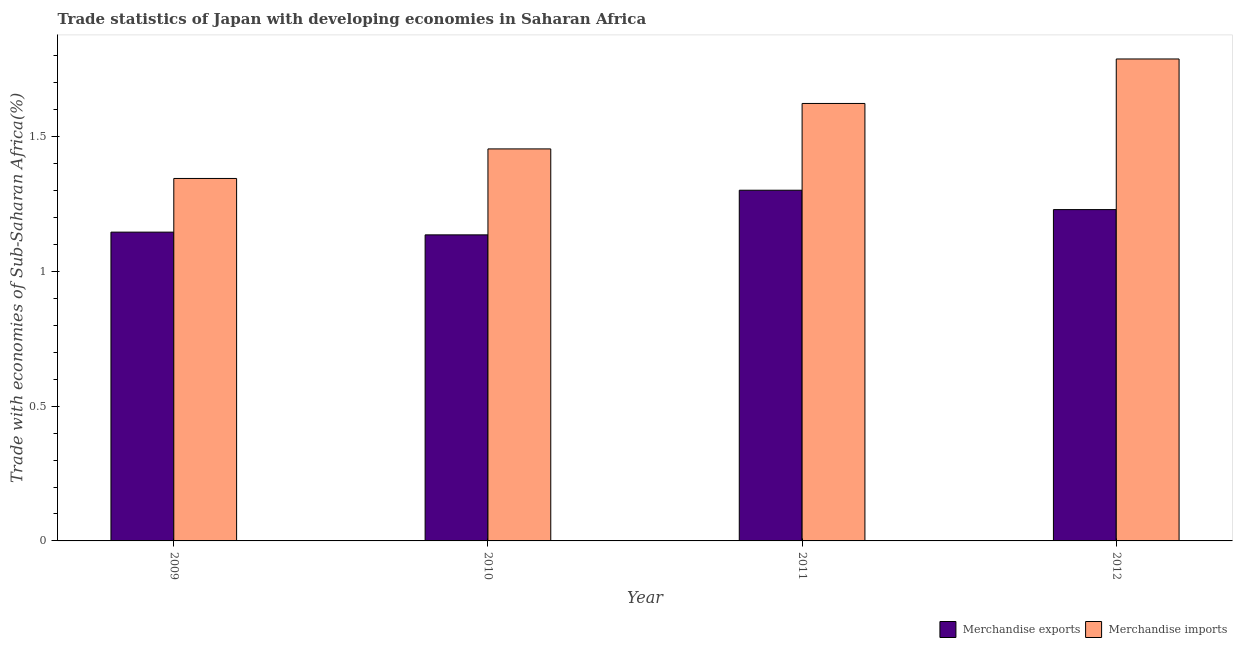Are the number of bars on each tick of the X-axis equal?
Your answer should be compact. Yes. How many bars are there on the 2nd tick from the left?
Your answer should be compact. 2. How many bars are there on the 2nd tick from the right?
Keep it short and to the point. 2. What is the label of the 3rd group of bars from the left?
Your answer should be compact. 2011. What is the merchandise imports in 2009?
Your answer should be very brief. 1.35. Across all years, what is the maximum merchandise exports?
Give a very brief answer. 1.3. Across all years, what is the minimum merchandise imports?
Ensure brevity in your answer.  1.35. In which year was the merchandise imports minimum?
Your answer should be compact. 2009. What is the total merchandise exports in the graph?
Offer a very short reply. 4.81. What is the difference between the merchandise imports in 2011 and that in 2012?
Ensure brevity in your answer.  -0.17. What is the difference between the merchandise exports in 2012 and the merchandise imports in 2009?
Make the answer very short. 0.08. What is the average merchandise imports per year?
Provide a short and direct response. 1.55. What is the ratio of the merchandise exports in 2010 to that in 2011?
Give a very brief answer. 0.87. What is the difference between the highest and the second highest merchandise imports?
Your answer should be compact. 0.17. What is the difference between the highest and the lowest merchandise exports?
Offer a terse response. 0.17. In how many years, is the merchandise exports greater than the average merchandise exports taken over all years?
Your response must be concise. 2. Is the sum of the merchandise imports in 2009 and 2010 greater than the maximum merchandise exports across all years?
Your answer should be compact. Yes. What does the 1st bar from the left in 2011 represents?
Your response must be concise. Merchandise exports. What does the 1st bar from the right in 2011 represents?
Offer a very short reply. Merchandise imports. How many bars are there?
Make the answer very short. 8. Are all the bars in the graph horizontal?
Ensure brevity in your answer.  No. Are the values on the major ticks of Y-axis written in scientific E-notation?
Your answer should be very brief. No. Does the graph contain grids?
Make the answer very short. No. How are the legend labels stacked?
Provide a short and direct response. Horizontal. What is the title of the graph?
Offer a terse response. Trade statistics of Japan with developing economies in Saharan Africa. What is the label or title of the Y-axis?
Your answer should be compact. Trade with economies of Sub-Saharan Africa(%). What is the Trade with economies of Sub-Saharan Africa(%) in Merchandise exports in 2009?
Provide a short and direct response. 1.15. What is the Trade with economies of Sub-Saharan Africa(%) in Merchandise imports in 2009?
Provide a succinct answer. 1.35. What is the Trade with economies of Sub-Saharan Africa(%) in Merchandise exports in 2010?
Offer a terse response. 1.14. What is the Trade with economies of Sub-Saharan Africa(%) of Merchandise imports in 2010?
Your answer should be very brief. 1.46. What is the Trade with economies of Sub-Saharan Africa(%) of Merchandise exports in 2011?
Offer a very short reply. 1.3. What is the Trade with economies of Sub-Saharan Africa(%) in Merchandise imports in 2011?
Your response must be concise. 1.62. What is the Trade with economies of Sub-Saharan Africa(%) of Merchandise exports in 2012?
Keep it short and to the point. 1.23. What is the Trade with economies of Sub-Saharan Africa(%) of Merchandise imports in 2012?
Make the answer very short. 1.79. Across all years, what is the maximum Trade with economies of Sub-Saharan Africa(%) in Merchandise exports?
Your answer should be compact. 1.3. Across all years, what is the maximum Trade with economies of Sub-Saharan Africa(%) in Merchandise imports?
Your answer should be compact. 1.79. Across all years, what is the minimum Trade with economies of Sub-Saharan Africa(%) in Merchandise exports?
Keep it short and to the point. 1.14. Across all years, what is the minimum Trade with economies of Sub-Saharan Africa(%) of Merchandise imports?
Give a very brief answer. 1.35. What is the total Trade with economies of Sub-Saharan Africa(%) of Merchandise exports in the graph?
Offer a very short reply. 4.81. What is the total Trade with economies of Sub-Saharan Africa(%) of Merchandise imports in the graph?
Offer a very short reply. 6.21. What is the difference between the Trade with economies of Sub-Saharan Africa(%) of Merchandise exports in 2009 and that in 2010?
Offer a very short reply. 0.01. What is the difference between the Trade with economies of Sub-Saharan Africa(%) of Merchandise imports in 2009 and that in 2010?
Give a very brief answer. -0.11. What is the difference between the Trade with economies of Sub-Saharan Africa(%) in Merchandise exports in 2009 and that in 2011?
Offer a terse response. -0.16. What is the difference between the Trade with economies of Sub-Saharan Africa(%) of Merchandise imports in 2009 and that in 2011?
Provide a succinct answer. -0.28. What is the difference between the Trade with economies of Sub-Saharan Africa(%) in Merchandise exports in 2009 and that in 2012?
Offer a terse response. -0.08. What is the difference between the Trade with economies of Sub-Saharan Africa(%) in Merchandise imports in 2009 and that in 2012?
Offer a very short reply. -0.44. What is the difference between the Trade with economies of Sub-Saharan Africa(%) in Merchandise exports in 2010 and that in 2011?
Your answer should be compact. -0.17. What is the difference between the Trade with economies of Sub-Saharan Africa(%) of Merchandise imports in 2010 and that in 2011?
Ensure brevity in your answer.  -0.17. What is the difference between the Trade with economies of Sub-Saharan Africa(%) in Merchandise exports in 2010 and that in 2012?
Provide a succinct answer. -0.09. What is the difference between the Trade with economies of Sub-Saharan Africa(%) in Merchandise imports in 2010 and that in 2012?
Keep it short and to the point. -0.33. What is the difference between the Trade with economies of Sub-Saharan Africa(%) of Merchandise exports in 2011 and that in 2012?
Keep it short and to the point. 0.07. What is the difference between the Trade with economies of Sub-Saharan Africa(%) of Merchandise imports in 2011 and that in 2012?
Your response must be concise. -0.17. What is the difference between the Trade with economies of Sub-Saharan Africa(%) of Merchandise exports in 2009 and the Trade with economies of Sub-Saharan Africa(%) of Merchandise imports in 2010?
Your response must be concise. -0.31. What is the difference between the Trade with economies of Sub-Saharan Africa(%) in Merchandise exports in 2009 and the Trade with economies of Sub-Saharan Africa(%) in Merchandise imports in 2011?
Keep it short and to the point. -0.48. What is the difference between the Trade with economies of Sub-Saharan Africa(%) of Merchandise exports in 2009 and the Trade with economies of Sub-Saharan Africa(%) of Merchandise imports in 2012?
Ensure brevity in your answer.  -0.64. What is the difference between the Trade with economies of Sub-Saharan Africa(%) of Merchandise exports in 2010 and the Trade with economies of Sub-Saharan Africa(%) of Merchandise imports in 2011?
Your answer should be very brief. -0.49. What is the difference between the Trade with economies of Sub-Saharan Africa(%) in Merchandise exports in 2010 and the Trade with economies of Sub-Saharan Africa(%) in Merchandise imports in 2012?
Your answer should be very brief. -0.65. What is the difference between the Trade with economies of Sub-Saharan Africa(%) of Merchandise exports in 2011 and the Trade with economies of Sub-Saharan Africa(%) of Merchandise imports in 2012?
Make the answer very short. -0.49. What is the average Trade with economies of Sub-Saharan Africa(%) of Merchandise exports per year?
Provide a succinct answer. 1.2. What is the average Trade with economies of Sub-Saharan Africa(%) of Merchandise imports per year?
Your answer should be compact. 1.55. In the year 2009, what is the difference between the Trade with economies of Sub-Saharan Africa(%) in Merchandise exports and Trade with economies of Sub-Saharan Africa(%) in Merchandise imports?
Offer a terse response. -0.2. In the year 2010, what is the difference between the Trade with economies of Sub-Saharan Africa(%) of Merchandise exports and Trade with economies of Sub-Saharan Africa(%) of Merchandise imports?
Keep it short and to the point. -0.32. In the year 2011, what is the difference between the Trade with economies of Sub-Saharan Africa(%) in Merchandise exports and Trade with economies of Sub-Saharan Africa(%) in Merchandise imports?
Give a very brief answer. -0.32. In the year 2012, what is the difference between the Trade with economies of Sub-Saharan Africa(%) in Merchandise exports and Trade with economies of Sub-Saharan Africa(%) in Merchandise imports?
Keep it short and to the point. -0.56. What is the ratio of the Trade with economies of Sub-Saharan Africa(%) of Merchandise exports in 2009 to that in 2010?
Make the answer very short. 1.01. What is the ratio of the Trade with economies of Sub-Saharan Africa(%) in Merchandise imports in 2009 to that in 2010?
Keep it short and to the point. 0.92. What is the ratio of the Trade with economies of Sub-Saharan Africa(%) in Merchandise exports in 2009 to that in 2011?
Your response must be concise. 0.88. What is the ratio of the Trade with economies of Sub-Saharan Africa(%) of Merchandise imports in 2009 to that in 2011?
Provide a succinct answer. 0.83. What is the ratio of the Trade with economies of Sub-Saharan Africa(%) of Merchandise exports in 2009 to that in 2012?
Provide a short and direct response. 0.93. What is the ratio of the Trade with economies of Sub-Saharan Africa(%) of Merchandise imports in 2009 to that in 2012?
Your answer should be compact. 0.75. What is the ratio of the Trade with economies of Sub-Saharan Africa(%) of Merchandise exports in 2010 to that in 2011?
Give a very brief answer. 0.87. What is the ratio of the Trade with economies of Sub-Saharan Africa(%) in Merchandise imports in 2010 to that in 2011?
Give a very brief answer. 0.9. What is the ratio of the Trade with economies of Sub-Saharan Africa(%) in Merchandise exports in 2010 to that in 2012?
Make the answer very short. 0.92. What is the ratio of the Trade with economies of Sub-Saharan Africa(%) in Merchandise imports in 2010 to that in 2012?
Make the answer very short. 0.81. What is the ratio of the Trade with economies of Sub-Saharan Africa(%) in Merchandise exports in 2011 to that in 2012?
Your answer should be compact. 1.06. What is the ratio of the Trade with economies of Sub-Saharan Africa(%) in Merchandise imports in 2011 to that in 2012?
Your response must be concise. 0.91. What is the difference between the highest and the second highest Trade with economies of Sub-Saharan Africa(%) in Merchandise exports?
Offer a very short reply. 0.07. What is the difference between the highest and the second highest Trade with economies of Sub-Saharan Africa(%) in Merchandise imports?
Provide a succinct answer. 0.17. What is the difference between the highest and the lowest Trade with economies of Sub-Saharan Africa(%) of Merchandise exports?
Your answer should be compact. 0.17. What is the difference between the highest and the lowest Trade with economies of Sub-Saharan Africa(%) in Merchandise imports?
Provide a short and direct response. 0.44. 